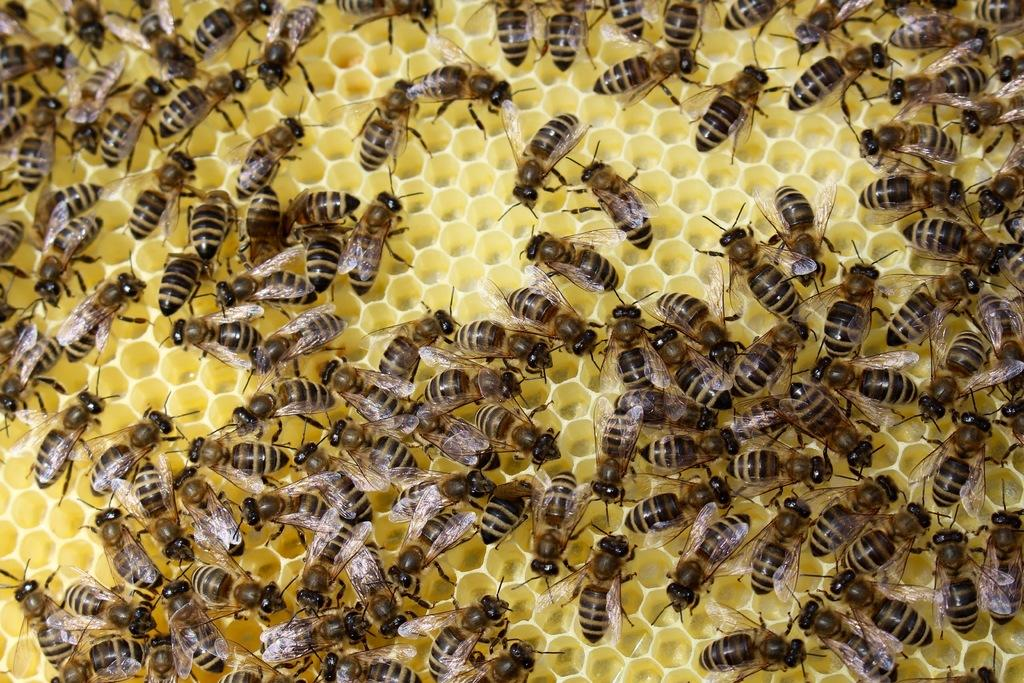What type of insects are present in the image? There are honey-bees in the image. What surface are the honey-bees situated on? The honey-bees are on a mesh. Can you describe the mesh in the image? The mesh has holes. What is the color of the background in the image? The background of the image is yellow in color. What type of hat is the honey-bee wearing in the image? There is no hat present in the image, as honey-bees do not wear hats. What song is the honey-bee singing in the image? There is no indication in the image that the honey-bee is singing a song. 